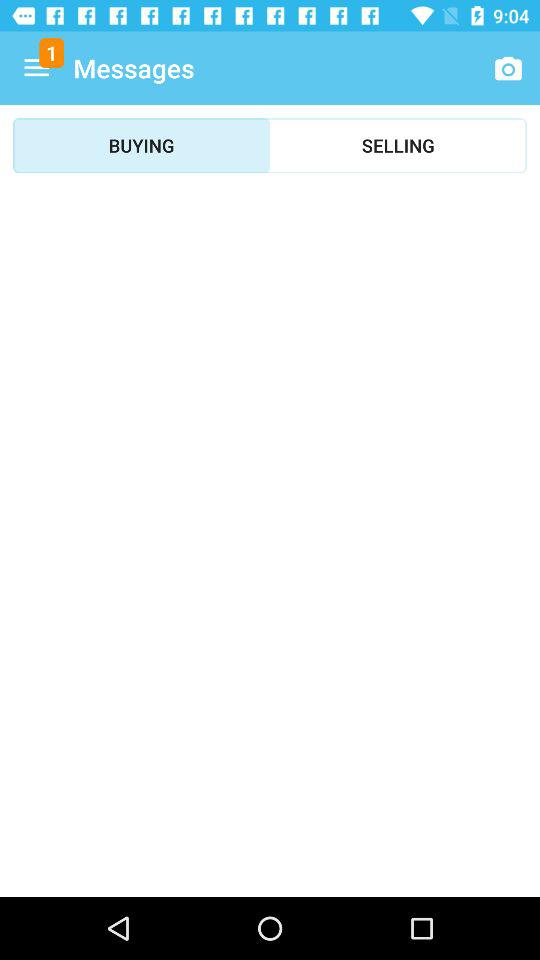How many notifications are in the menu? There is 1 notification. 